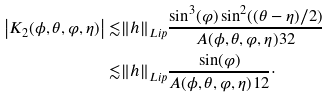<formula> <loc_0><loc_0><loc_500><loc_500>\left | K _ { 2 } ( \phi , \theta , \varphi , \eta ) \right | \lesssim & \| h \| _ { L i p } \frac { \sin ^ { 3 } ( \varphi ) \sin ^ { 2 } ( ( \theta - \eta ) / 2 ) } { A ( \phi , \theta , \varphi , \eta ) ^ { } { 3 } 2 } \\ \lesssim & \| h \| _ { L i p } \frac { \sin ( \varphi ) } { A ( \phi , \theta , \varphi , \eta ) ^ { } { 1 } 2 } \cdot</formula> 